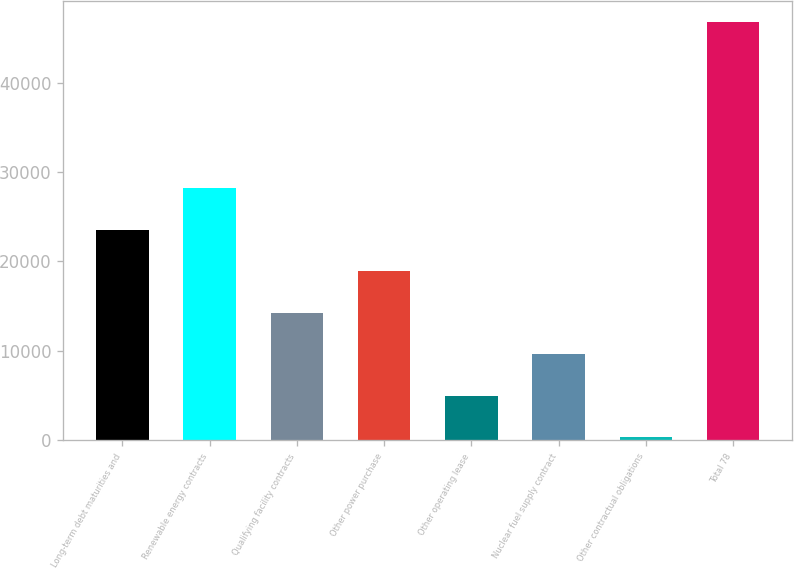Convert chart to OTSL. <chart><loc_0><loc_0><loc_500><loc_500><bar_chart><fcel>Long-term debt maturities and<fcel>Renewable energy contracts<fcel>Qualifying facility contracts<fcel>Other power purchase<fcel>Other operating lease<fcel>Nuclear fuel supply contract<fcel>Other contractual obligations<fcel>Total 78<nl><fcel>23563<fcel>28211<fcel>14267<fcel>18915<fcel>4971<fcel>9619<fcel>323<fcel>46803<nl></chart> 